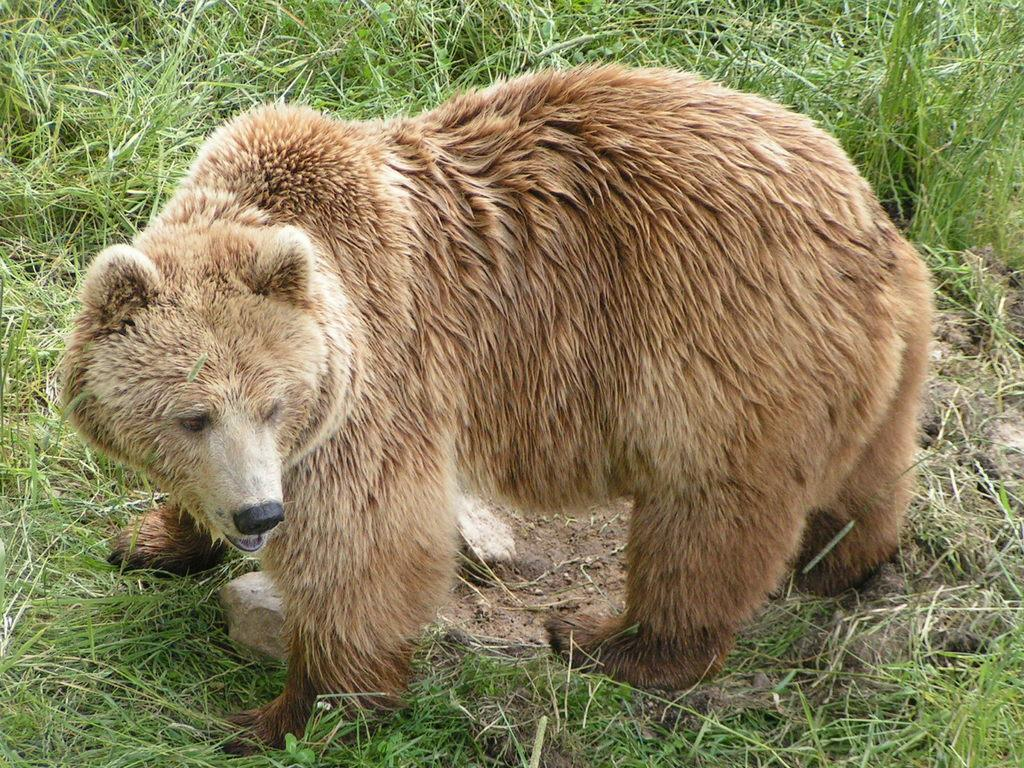What type of animal is in the image? There is a bear in the image. What is the bear standing on or near in the image? There is a stone in the image. What type of vegetation is present in the image? There is grass in the image. What is the price of the copper in the image? There is no copper present in the image, so it is not possible to determine its price. 